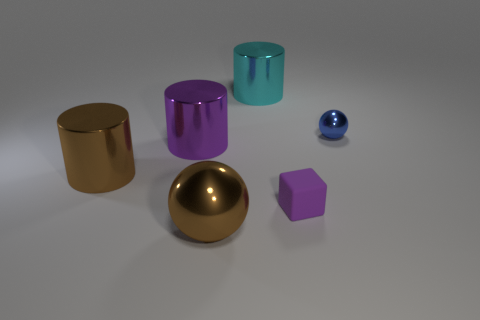Are there any other things that are made of the same material as the purple block?
Give a very brief answer. No. What material is the purple thing right of the large metallic object behind the ball behind the purple rubber cube?
Provide a succinct answer. Rubber. What number of tiny objects are red things or brown shiny balls?
Provide a short and direct response. 0. What number of other objects are the same size as the cyan shiny cylinder?
Offer a very short reply. 3. There is a big brown metal thing that is in front of the small matte thing; is its shape the same as the tiny blue object?
Your response must be concise. Yes. There is a big object that is the same shape as the tiny blue metal thing; what color is it?
Keep it short and to the point. Brown. Is there any other thing that has the same shape as the purple shiny thing?
Your response must be concise. Yes. Are there the same number of cyan metallic cylinders that are behind the cyan thing and big yellow metallic cylinders?
Your answer should be very brief. Yes. How many metallic objects are in front of the small purple rubber thing and behind the tiny sphere?
Provide a succinct answer. 0. What size is the other brown object that is the same shape as the small metal object?
Your answer should be compact. Large. 